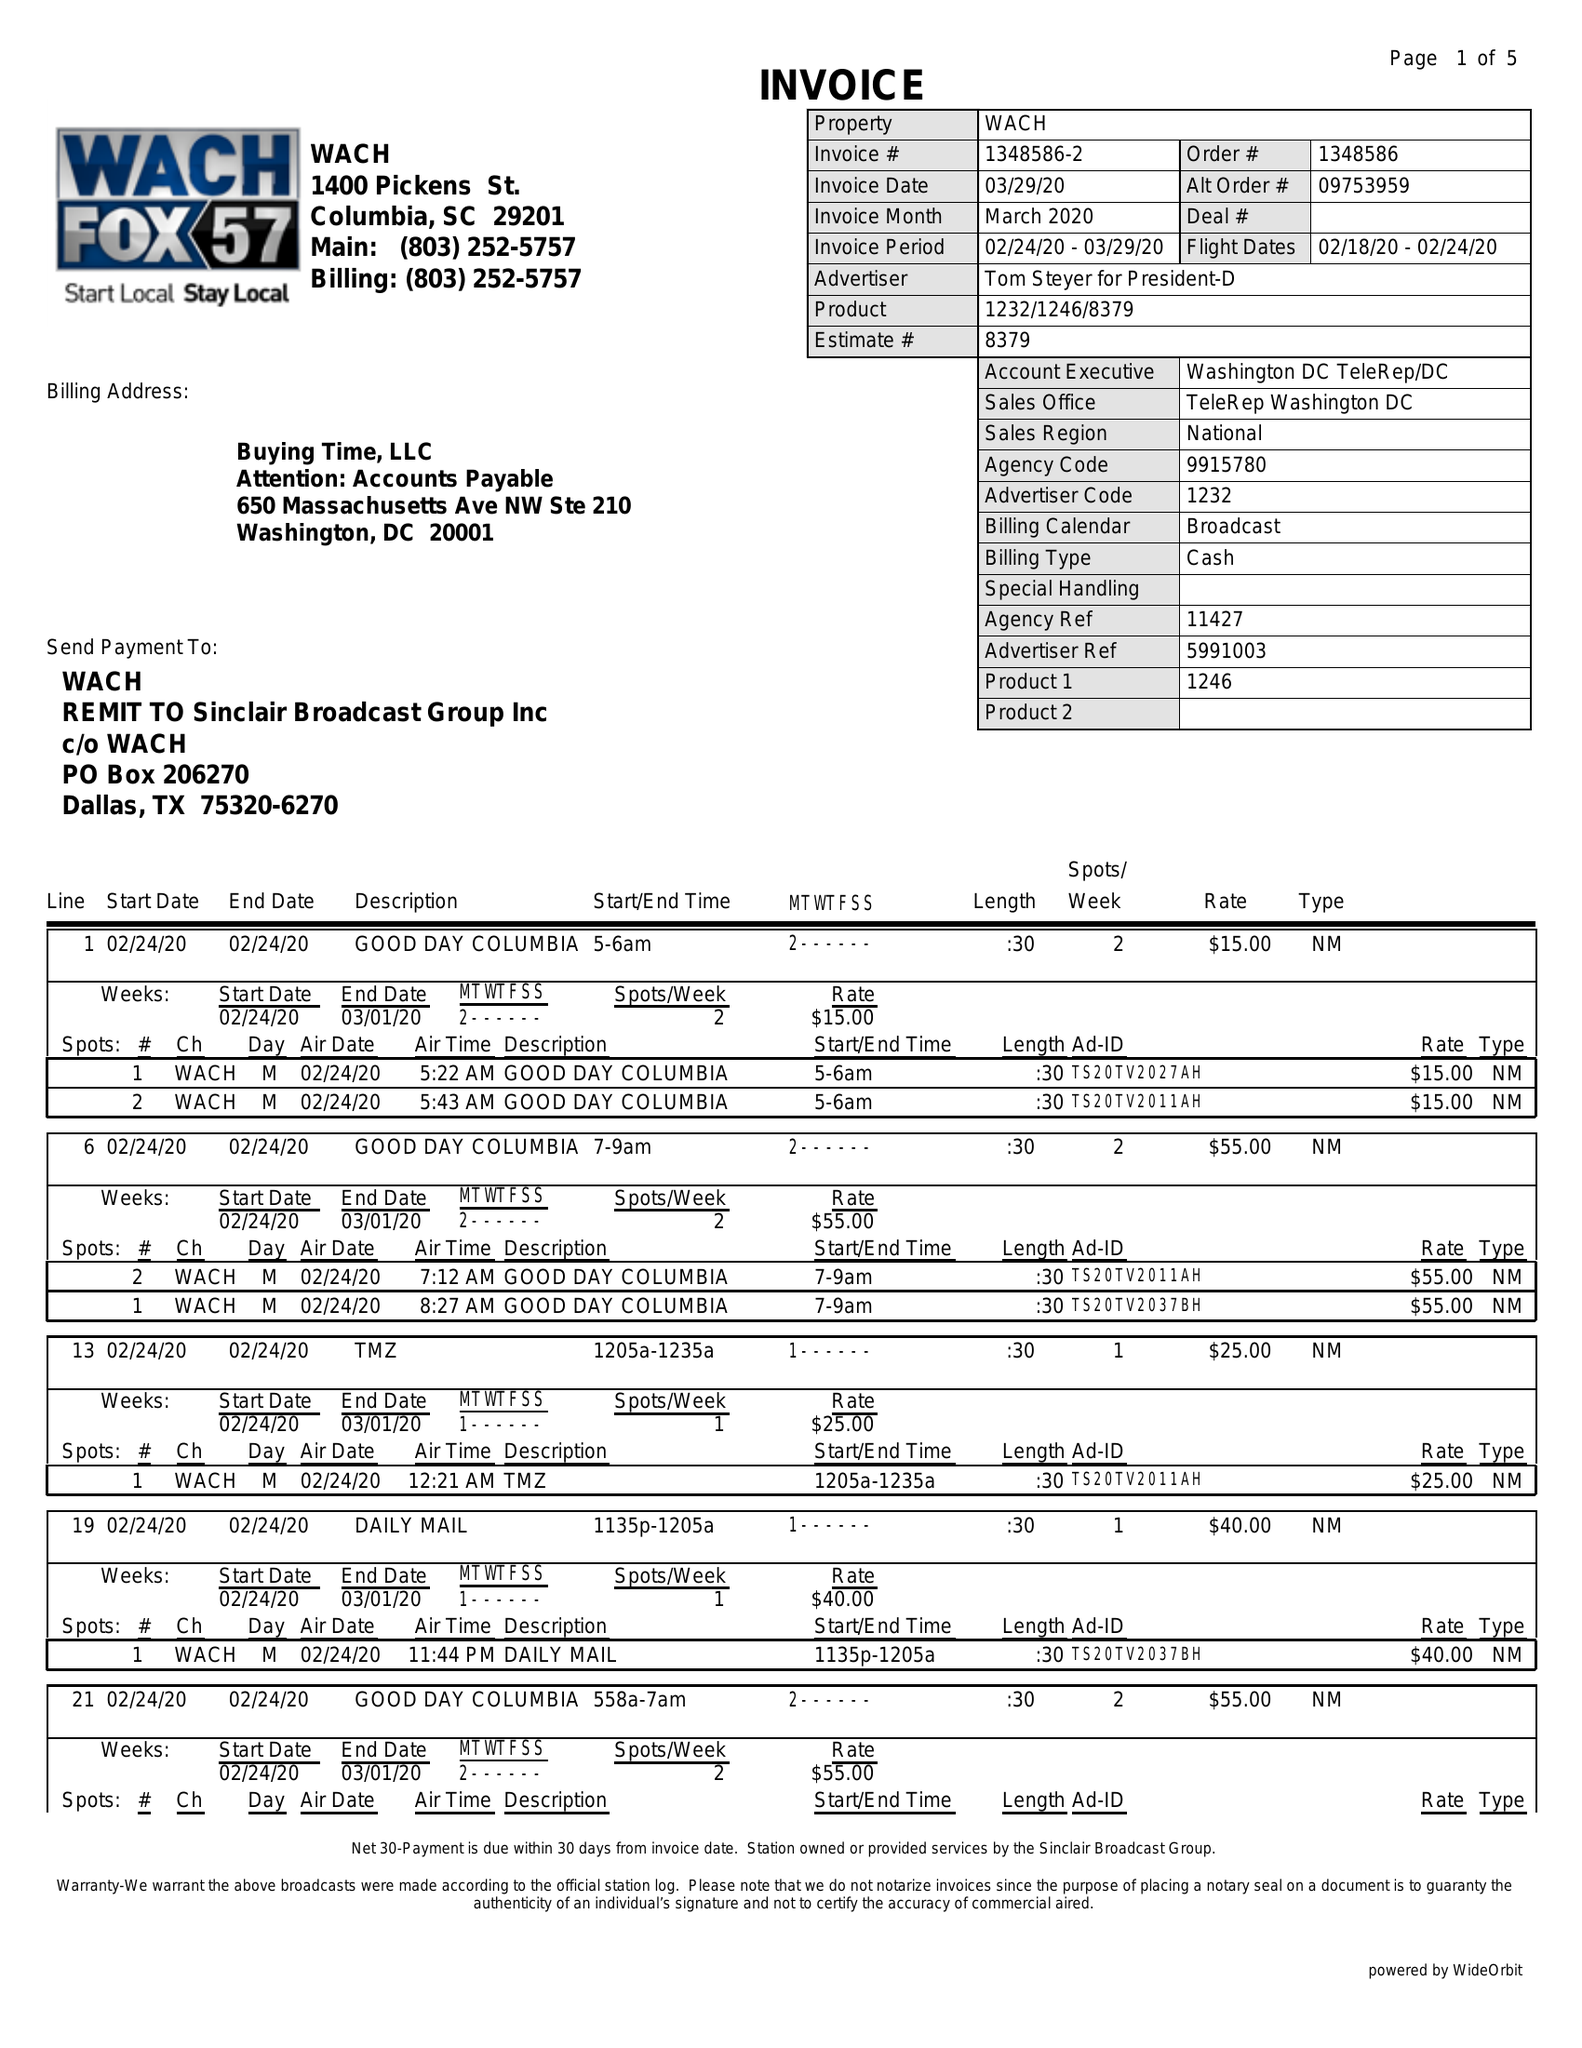What is the value for the contract_num?
Answer the question using a single word or phrase. 1348586 